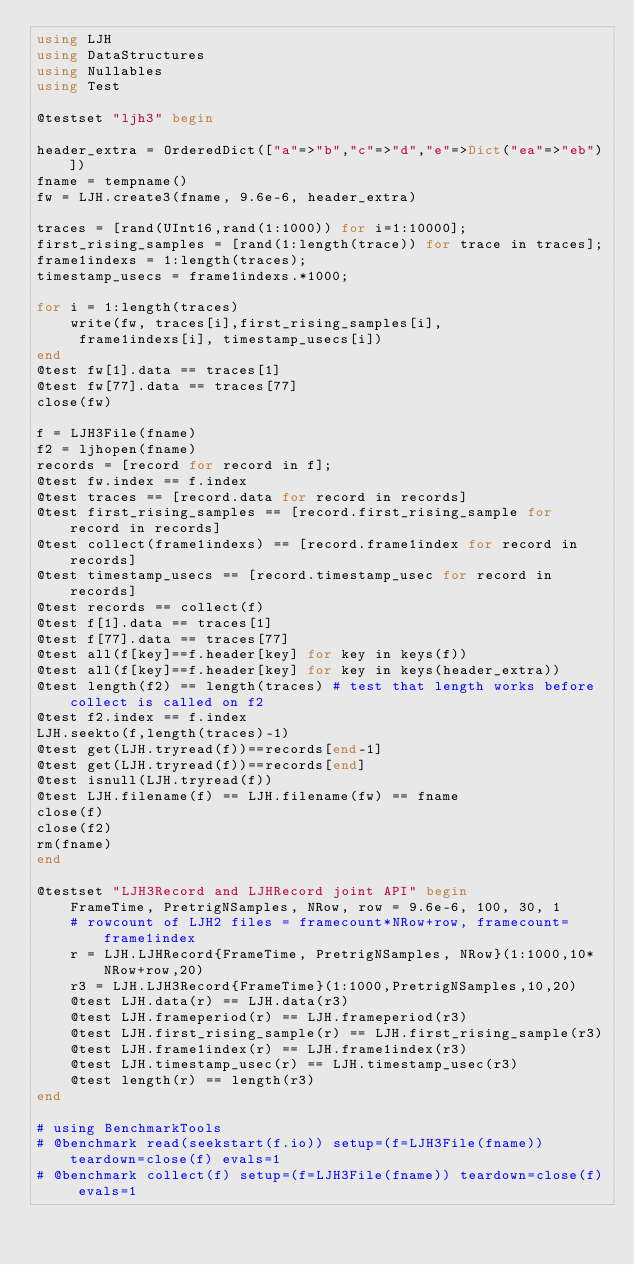Convert code to text. <code><loc_0><loc_0><loc_500><loc_500><_Julia_>using LJH
using DataStructures
using Nullables
using Test

@testset "ljh3" begin

header_extra = OrderedDict(["a"=>"b","c"=>"d","e"=>Dict("ea"=>"eb")])
fname = tempname()
fw = LJH.create3(fname, 9.6e-6, header_extra)

traces = [rand(UInt16,rand(1:1000)) for i=1:10000];
first_rising_samples = [rand(1:length(trace)) for trace in traces];
frame1indexs = 1:length(traces);
timestamp_usecs = frame1indexs.*1000;

for i = 1:length(traces)
    write(fw, traces[i],first_rising_samples[i],
     frame1indexs[i], timestamp_usecs[i])
end
@test fw[1].data == traces[1]
@test fw[77].data == traces[77]
close(fw)

f = LJH3File(fname)
f2 = ljhopen(fname)
records = [record for record in f];
@test fw.index == f.index
@test traces == [record.data for record in records]
@test first_rising_samples == [record.first_rising_sample for record in records]
@test collect(frame1indexs) == [record.frame1index for record in records]
@test timestamp_usecs == [record.timestamp_usec for record in records]
@test records == collect(f)
@test f[1].data == traces[1]
@test f[77].data == traces[77]
@test all(f[key]==f.header[key] for key in keys(f))
@test all(f[key]==f.header[key] for key in keys(header_extra))
@test length(f2) == length(traces) # test that length works before collect is called on f2
@test f2.index == f.index
LJH.seekto(f,length(traces)-1)
@test get(LJH.tryread(f))==records[end-1]
@test get(LJH.tryread(f))==records[end]
@test isnull(LJH.tryread(f))
@test LJH.filename(f) == LJH.filename(fw) == fname
close(f)
close(f2)
rm(fname)
end

@testset "LJH3Record and LJHRecord joint API" begin
    FrameTime, PretrigNSamples, NRow, row = 9.6e-6, 100, 30, 1
    # rowcount of LJH2 files = framecount*NRow+row, framecount=frame1index
    r = LJH.LJHRecord{FrameTime, PretrigNSamples, NRow}(1:1000,10*NRow+row,20)
    r3 = LJH.LJH3Record{FrameTime}(1:1000,PretrigNSamples,10,20)
    @test LJH.data(r) == LJH.data(r3)
    @test LJH.frameperiod(r) == LJH.frameperiod(r3)
    @test LJH.first_rising_sample(r) == LJH.first_rising_sample(r3)
    @test LJH.frame1index(r) == LJH.frame1index(r3)
    @test LJH.timestamp_usec(r) == LJH.timestamp_usec(r3)
    @test length(r) == length(r3)
end

# using BenchmarkTools
# @benchmark read(seekstart(f.io)) setup=(f=LJH3File(fname)) teardown=close(f) evals=1
# @benchmark collect(f) setup=(f=LJH3File(fname)) teardown=close(f) evals=1
</code> 